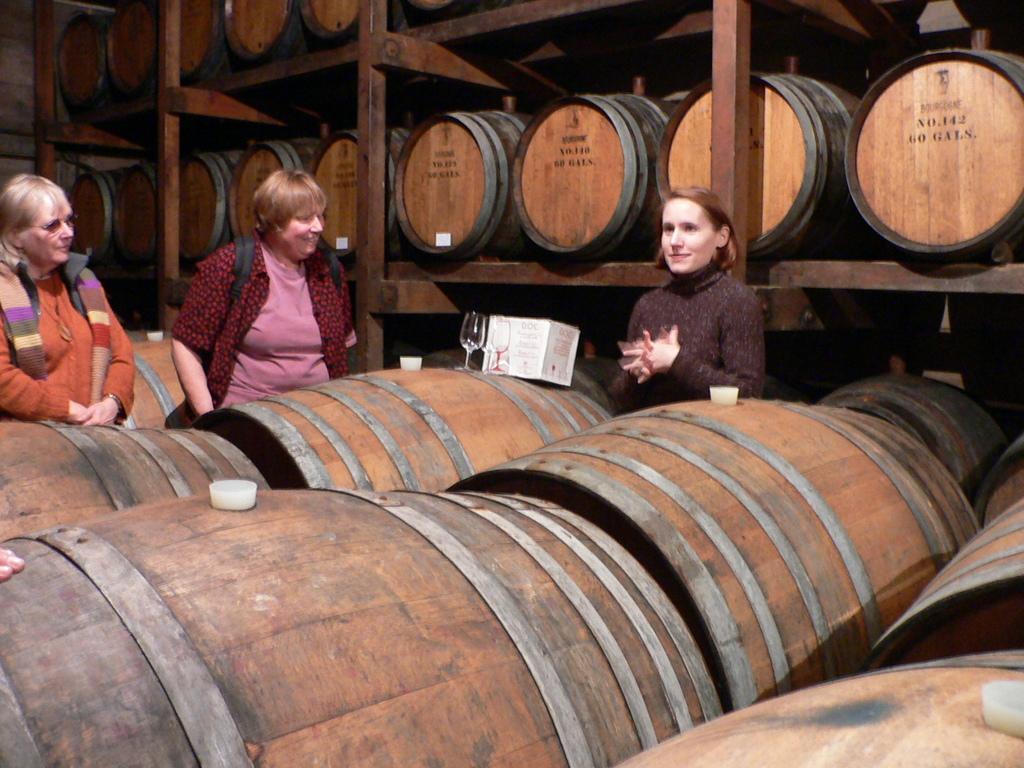Could you give a brief overview of what you see in this image? In this picture we can see there are three women standing. In front of the women there is a wine glass and a box on the barrel. On the left side of the women, we can see the fingers of a person. Behind the women there are barrels in the racks. 